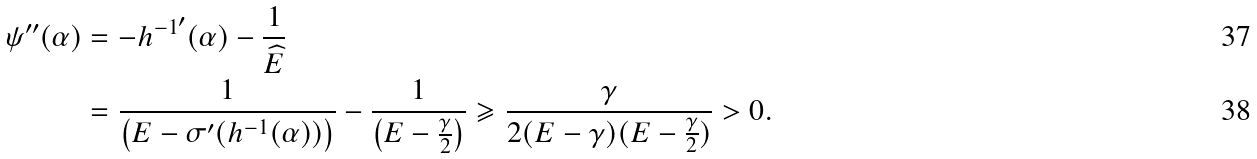<formula> <loc_0><loc_0><loc_500><loc_500>\psi ^ { \prime \prime } ( \alpha ) & = - { h ^ { - 1 } } ^ { \prime } ( \alpha ) - \frac { 1 } { \widehat { E } } \\ & = \frac { 1 } { \left ( E - \sigma ^ { \prime } ( h ^ { - 1 } ( \alpha ) ) \right ) } - \frac { 1 } { \left ( E - \frac { \gamma } { 2 } \right ) } \geqslant \frac { \gamma } { 2 ( E - \gamma ) ( E - \frac { \gamma } { 2 } ) } > 0 .</formula> 